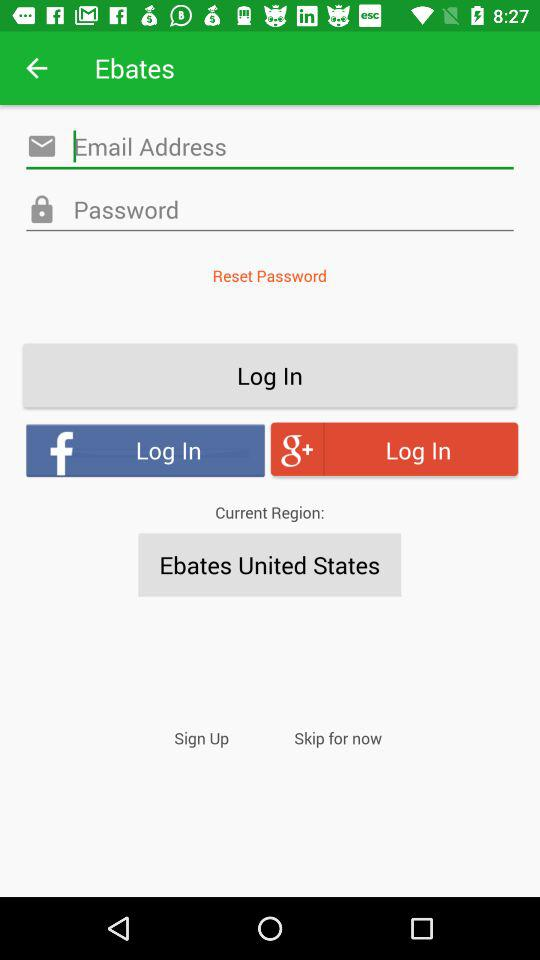What are the different applications through which we can log in? You can log in through "Facebook" and "Google+". 